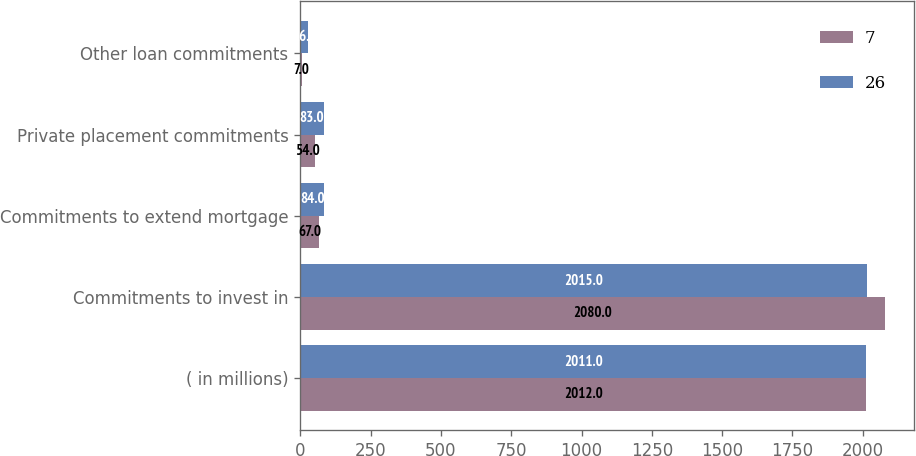<chart> <loc_0><loc_0><loc_500><loc_500><stacked_bar_chart><ecel><fcel>( in millions)<fcel>Commitments to invest in<fcel>Commitments to extend mortgage<fcel>Private placement commitments<fcel>Other loan commitments<nl><fcel>7<fcel>2012<fcel>2080<fcel>67<fcel>54<fcel>7<nl><fcel>26<fcel>2011<fcel>2015<fcel>84<fcel>83<fcel>26<nl></chart> 